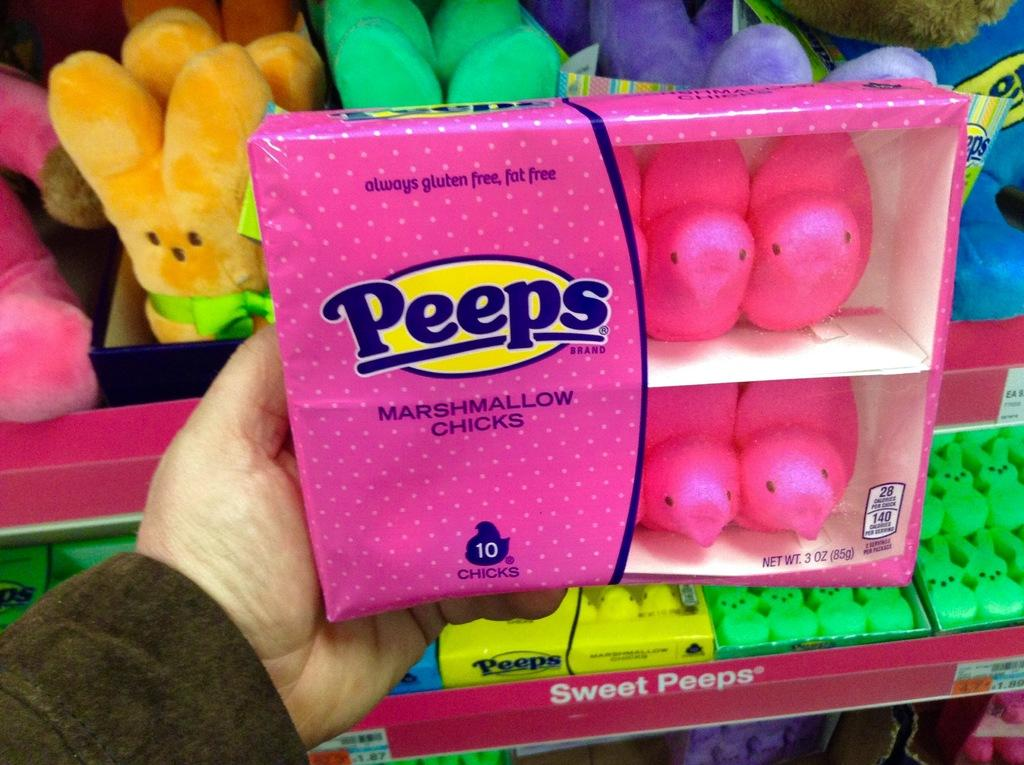What can be found in the racks in the image? There are toys in the racks. What is the person's hand holding in the image? A person's hand is holding a box. What is inside the box that the person is holding? There are marshmallow chicks inside the box. What type of credit card is being used to purchase the marshmallow chicks in the image? There is no credit card or purchase being depicted in the image; it only shows toys in racks, a person's hand holding a box, and marshmallow chicks inside the box. How does the person's stomach feel after eating the marshmallow chicks in the image? There is no indication in the image that the person has eaten any marshmallow chicks, so it cannot be determined how their stomach feels. 